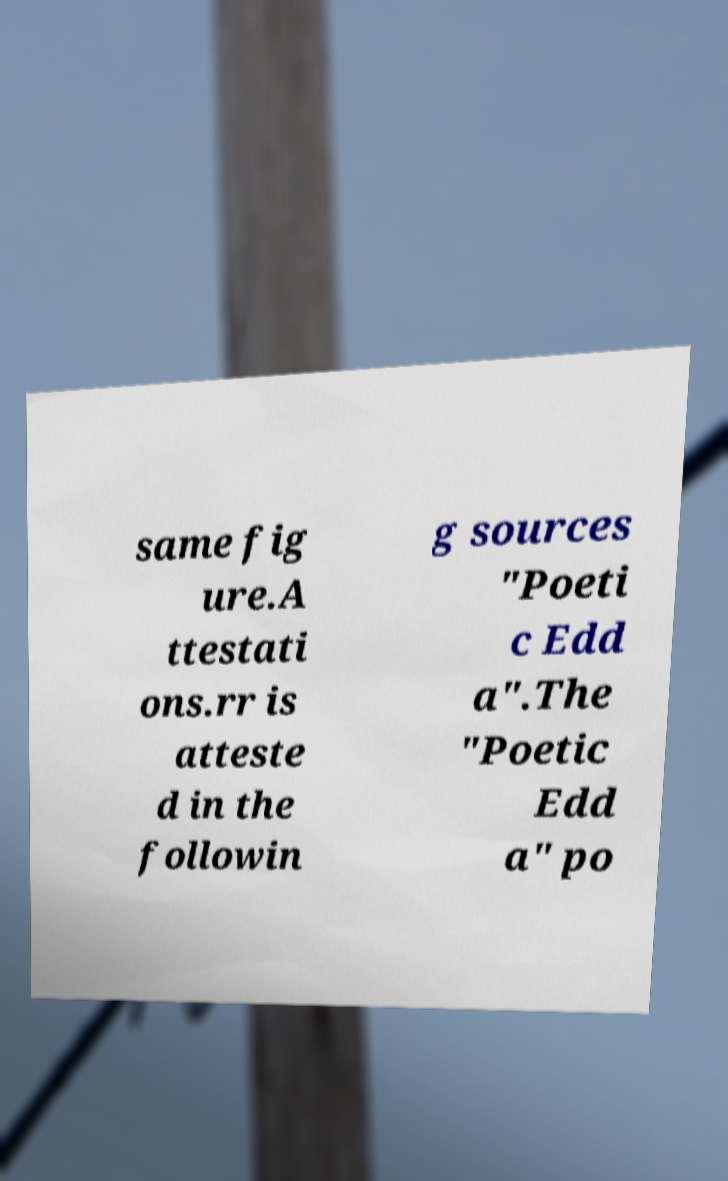For documentation purposes, I need the text within this image transcribed. Could you provide that? same fig ure.A ttestati ons.rr is atteste d in the followin g sources "Poeti c Edd a".The "Poetic Edd a" po 